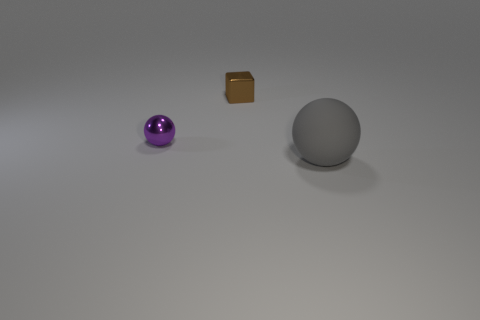Add 3 small red rubber spheres. How many objects exist? 6 Subtract all balls. How many objects are left? 1 Add 1 blocks. How many blocks are left? 2 Add 2 cylinders. How many cylinders exist? 2 Subtract 0 red cylinders. How many objects are left? 3 Subtract all small purple metal things. Subtract all big balls. How many objects are left? 1 